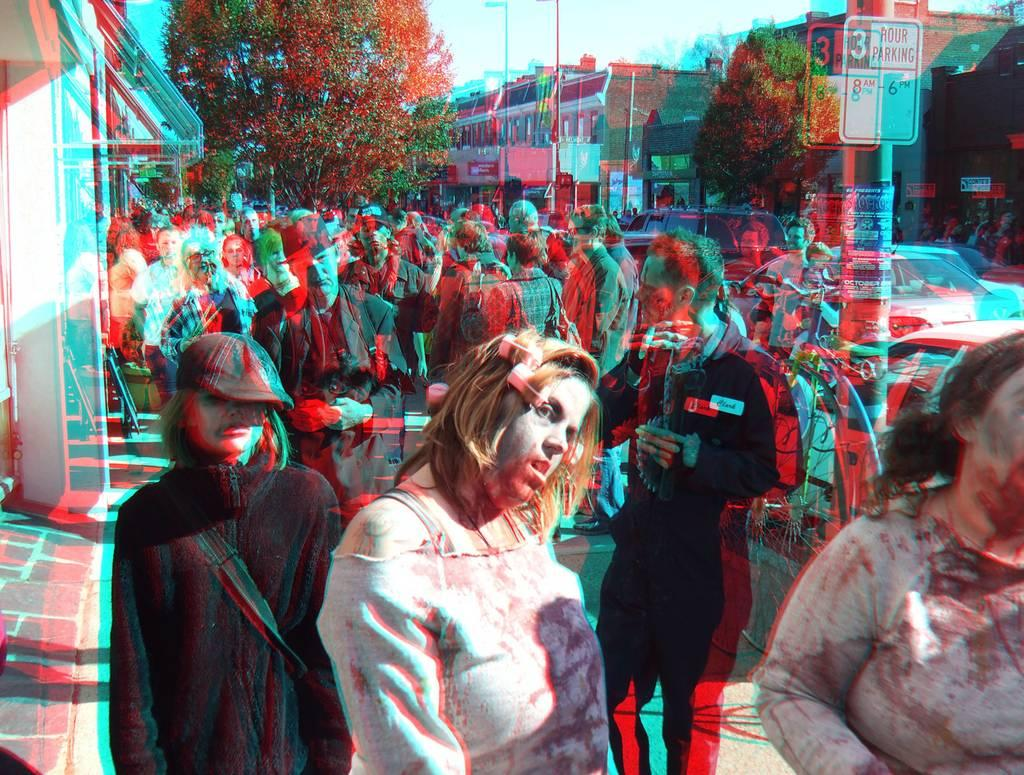What can be seen in the image? There are people standing, poles, boards, trees, vehicles, and buildings in the image. What is visible in the background of the image? The sky is visible in the background of the image. What type of silver is being served for breakfast in the image? There is no silver or breakfast present in the image. Who is delivering the parcel in the image? There is no parcel or delivery person present in the image. 